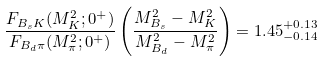<formula> <loc_0><loc_0><loc_500><loc_500>\frac { F _ { B _ { s } K } ( M _ { K } ^ { 2 } ; 0 ^ { + } ) } { F _ { B _ { d } \pi } ( M _ { \pi } ^ { 2 } ; 0 ^ { + } ) } \left ( \frac { M _ { B _ { s } } ^ { 2 } - M _ { K } ^ { 2 } } { M _ { B _ { d } } ^ { 2 } - M _ { \pi } ^ { 2 } } \right ) = 1 . 4 5 ^ { + 0 . 1 3 } _ { - 0 . 1 4 }</formula> 